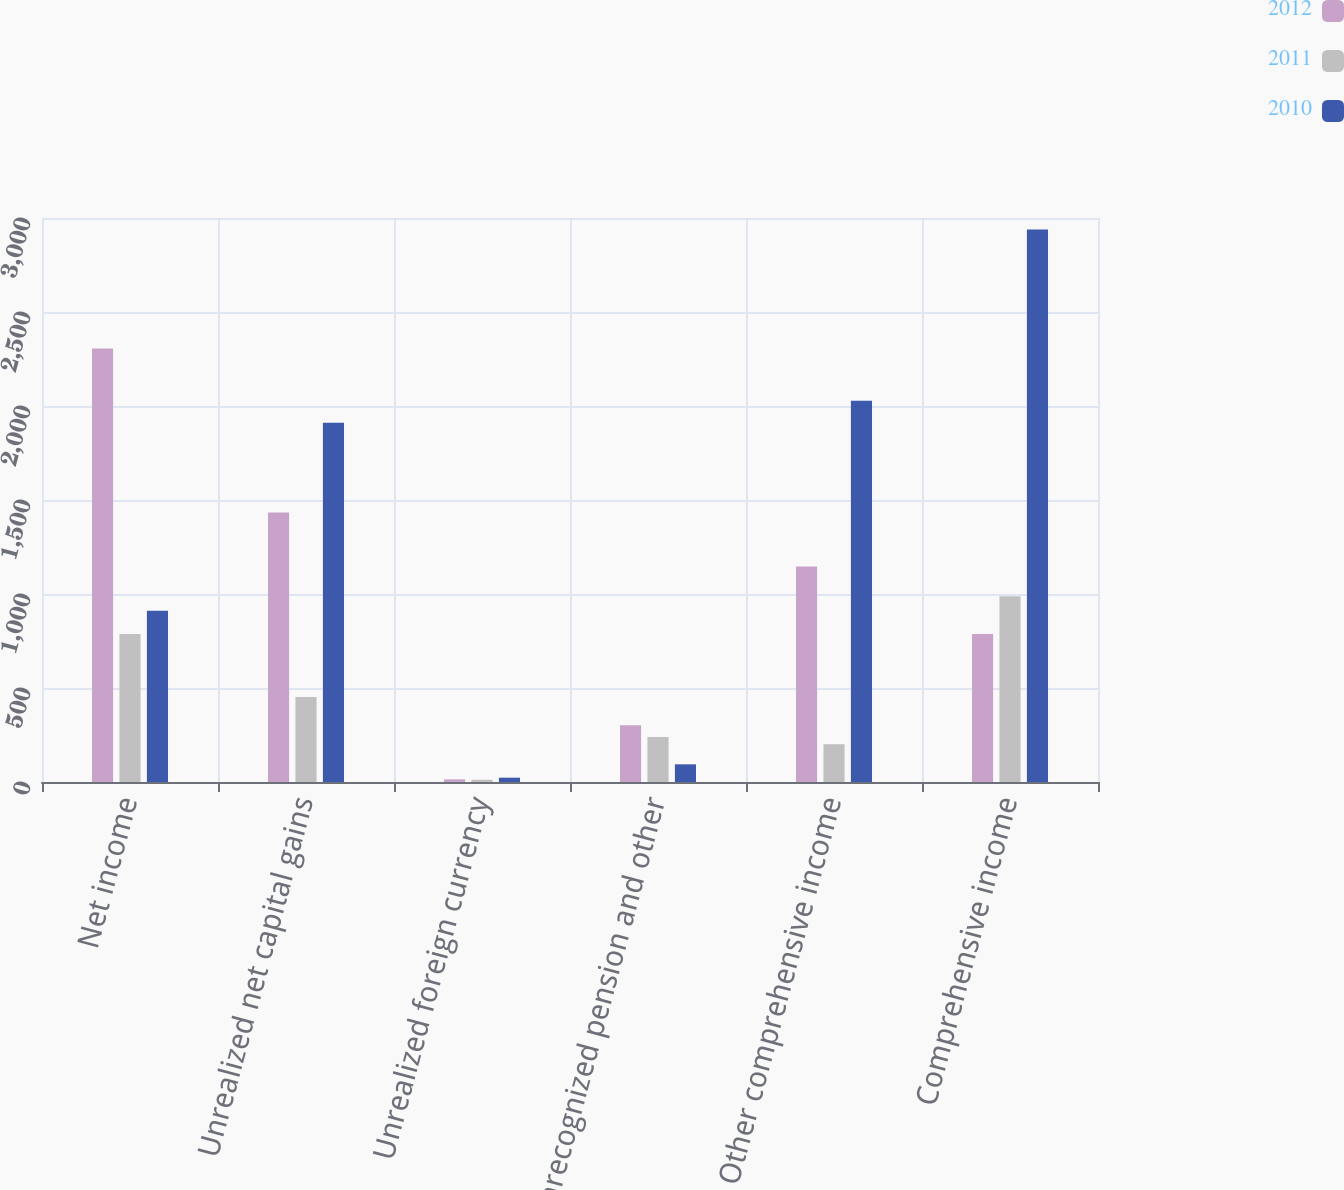Convert chart. <chart><loc_0><loc_0><loc_500><loc_500><stacked_bar_chart><ecel><fcel>Net income<fcel>Unrealized net capital gains<fcel>Unrealized foreign currency<fcel>Unrecognized pension and other<fcel>Other comprehensive income<fcel>Comprehensive income<nl><fcel>2012<fcel>2306<fcel>1434<fcel>14<fcel>302<fcel>1146<fcel>787<nl><fcel>2011<fcel>787<fcel>452<fcel>12<fcel>239<fcel>201<fcel>988<nl><fcel>2010<fcel>911<fcel>1911<fcel>23<fcel>94<fcel>2028<fcel>2939<nl></chart> 